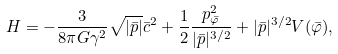Convert formula to latex. <formula><loc_0><loc_0><loc_500><loc_500>H = - \frac { 3 } { 8 \pi G \gamma ^ { 2 } } \sqrt { | \bar { p } | } \bar { c } ^ { 2 } + \frac { 1 } { 2 } \frac { p _ { \bar { \varphi } } ^ { 2 } } { | \bar { p } | ^ { 3 / 2 } } + | \bar { p } | ^ { 3 / 2 } V ( \bar { \varphi } ) ,</formula> 